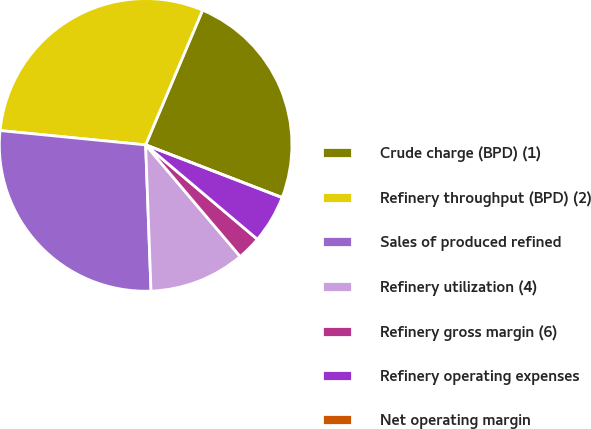Convert chart to OTSL. <chart><loc_0><loc_0><loc_500><loc_500><pie_chart><fcel>Crude charge (BPD) (1)<fcel>Refinery throughput (BPD) (2)<fcel>Sales of produced refined<fcel>Refinery utilization (4)<fcel>Refinery gross margin (6)<fcel>Refinery operating expenses<fcel>Net operating margin<nl><fcel>24.5%<fcel>29.8%<fcel>27.15%<fcel>10.6%<fcel>2.65%<fcel>5.3%<fcel>0.0%<nl></chart> 